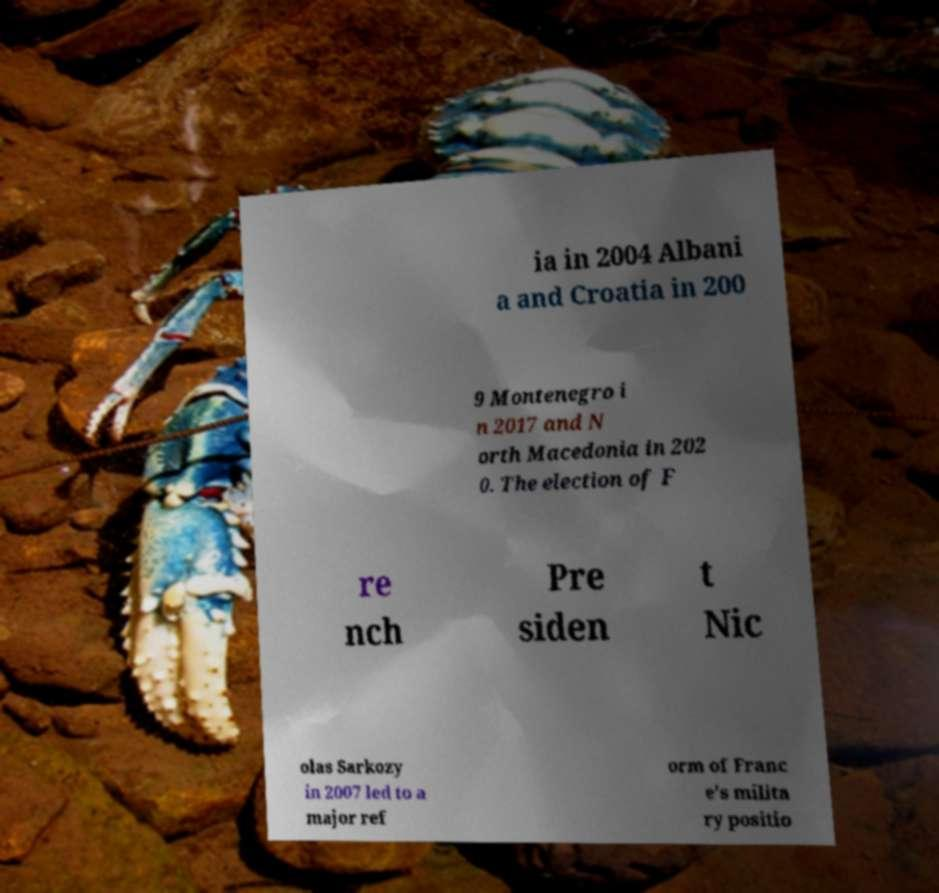Can you read and provide the text displayed in the image?This photo seems to have some interesting text. Can you extract and type it out for me? ia in 2004 Albani a and Croatia in 200 9 Montenegro i n 2017 and N orth Macedonia in 202 0. The election of F re nch Pre siden t Nic olas Sarkozy in 2007 led to a major ref orm of Franc e's milita ry positio 